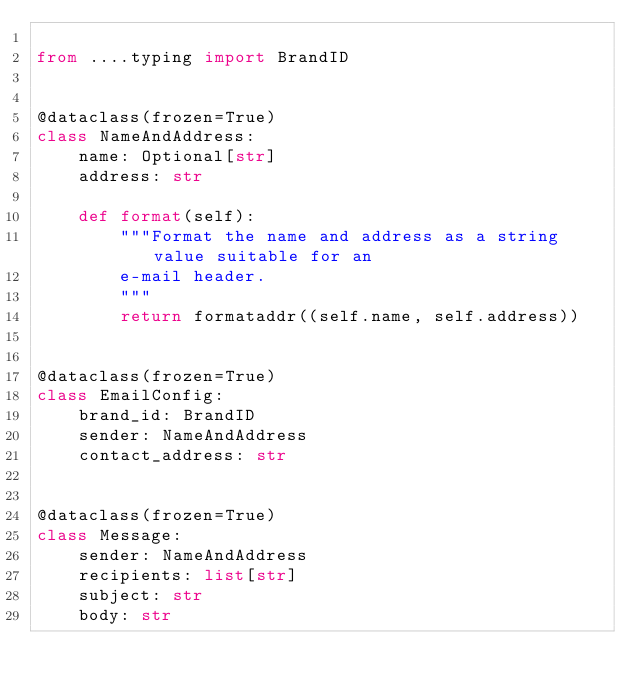<code> <loc_0><loc_0><loc_500><loc_500><_Python_>
from ....typing import BrandID


@dataclass(frozen=True)
class NameAndAddress:
    name: Optional[str]
    address: str

    def format(self):
        """Format the name and address as a string value suitable for an
        e-mail header.
        """
        return formataddr((self.name, self.address))


@dataclass(frozen=True)
class EmailConfig:
    brand_id: BrandID
    sender: NameAndAddress
    contact_address: str


@dataclass(frozen=True)
class Message:
    sender: NameAndAddress
    recipients: list[str]
    subject: str
    body: str
</code> 